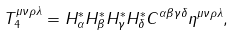Convert formula to latex. <formula><loc_0><loc_0><loc_500><loc_500>T _ { 4 } ^ { \mu \nu \rho \lambda } = H _ { \alpha } ^ { * } H _ { \beta } ^ { * } H _ { \gamma } ^ { * } H _ { \delta } ^ { * } C ^ { \alpha \beta \gamma \delta } \eta ^ { \mu \nu \rho \lambda } ,</formula> 